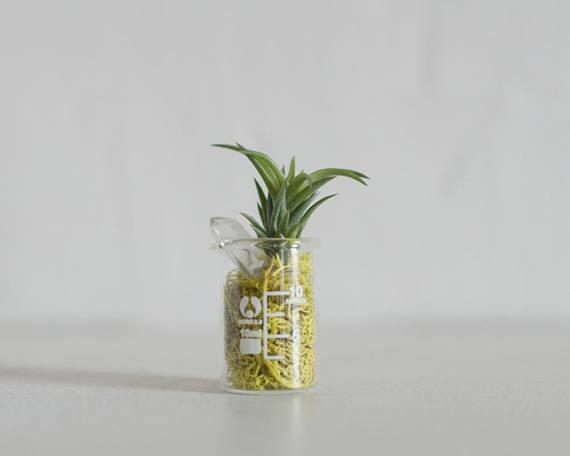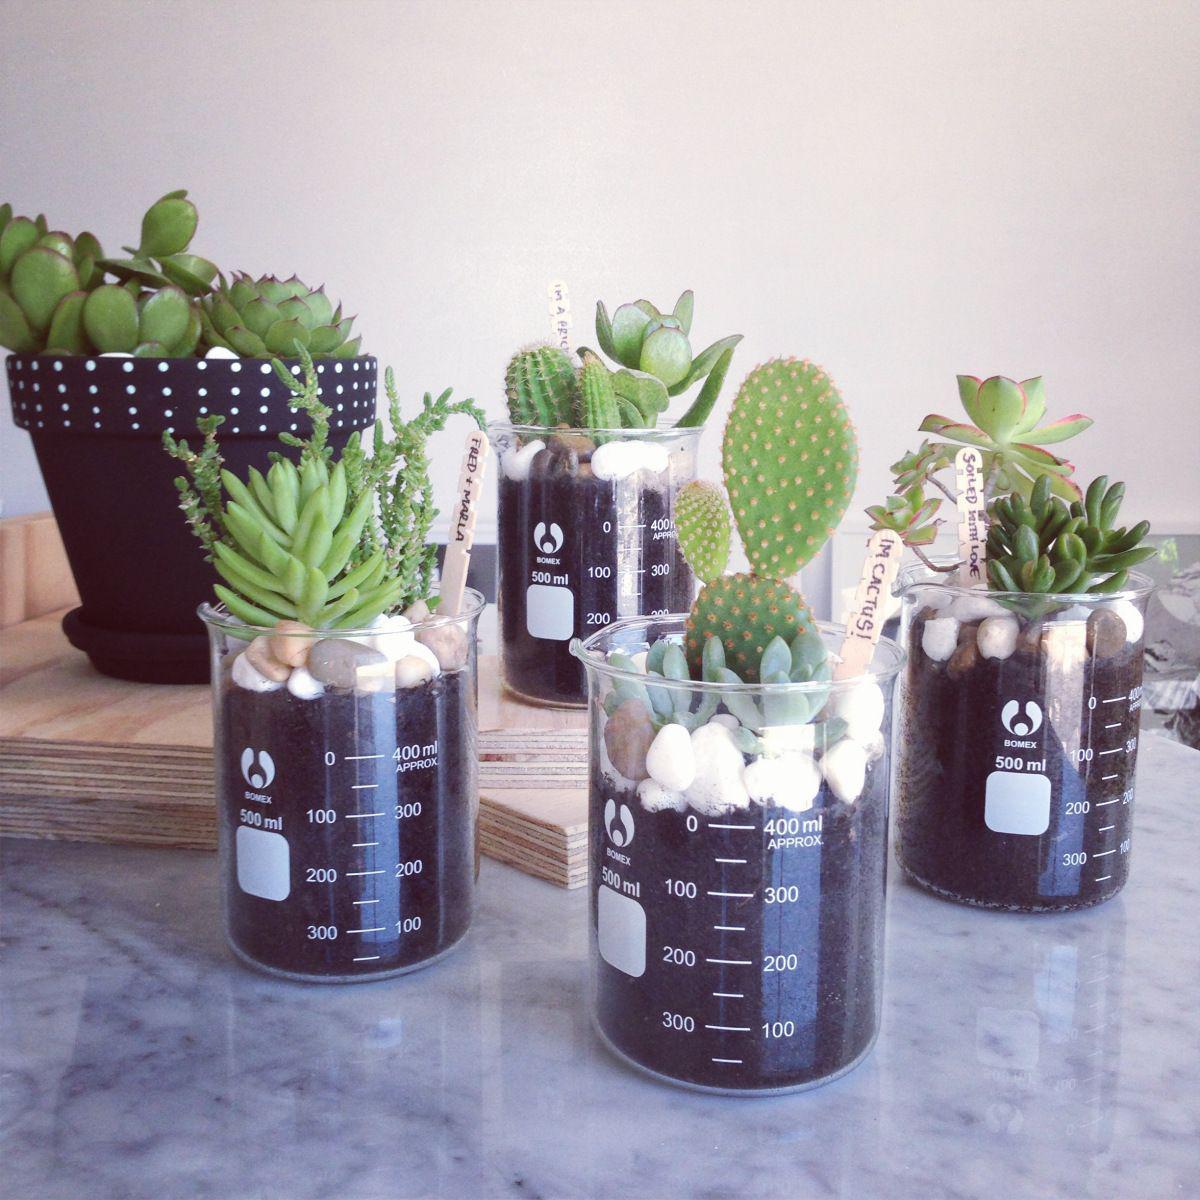The first image is the image on the left, the second image is the image on the right. Assess this claim about the two images: "There are exactly three plants in the left image.". Correct or not? Answer yes or no. No. The first image is the image on the left, the second image is the image on the right. Given the left and right images, does the statement "There is a total of 6 beakers and tubes with single plants or stems in it." hold true? Answer yes or no. No. 